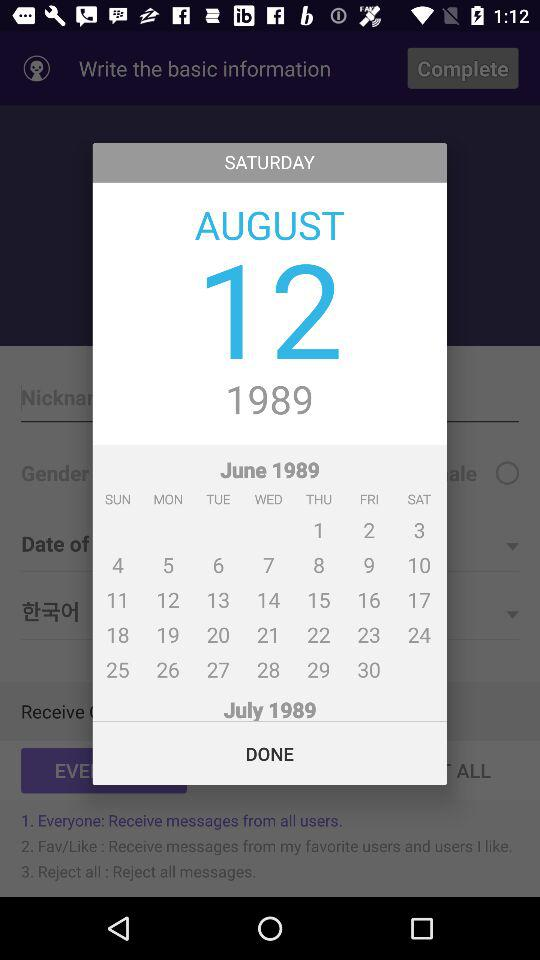What is the day on 18th of august?
When the provided information is insufficient, respond with <no answer>. <no answer> 